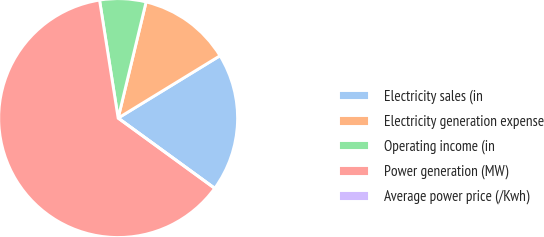<chart> <loc_0><loc_0><loc_500><loc_500><pie_chart><fcel>Electricity sales (in<fcel>Electricity generation expense<fcel>Operating income (in<fcel>Power generation (MW)<fcel>Average power price (/Kwh)<nl><fcel>18.75%<fcel>12.5%<fcel>6.25%<fcel>62.5%<fcel>0.0%<nl></chart> 